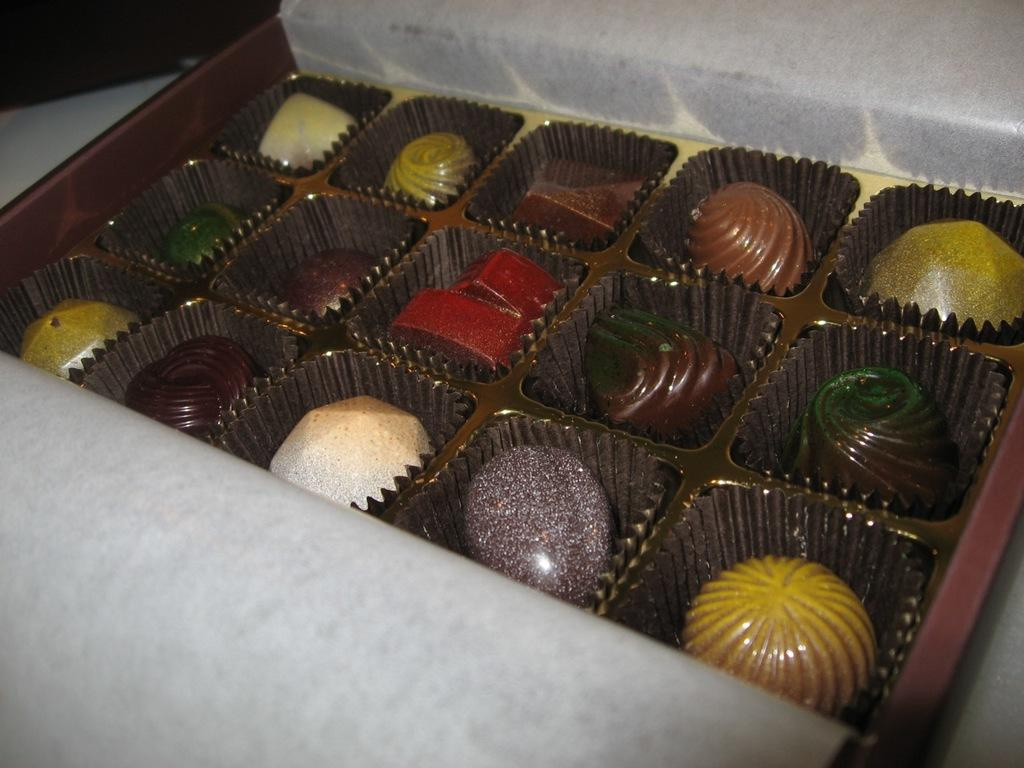What type of food is present in the image? There are chocolates in the image. How are the chocolates arranged or displayed? The chocolates are in a tray. What type of mountain is visible in the image? There is no mountain present in the image; it features chocolates in a tray. What type of badge is being worn by the chocolates in the image? There are no badges present in the image, as it only features chocolates in a tray. 